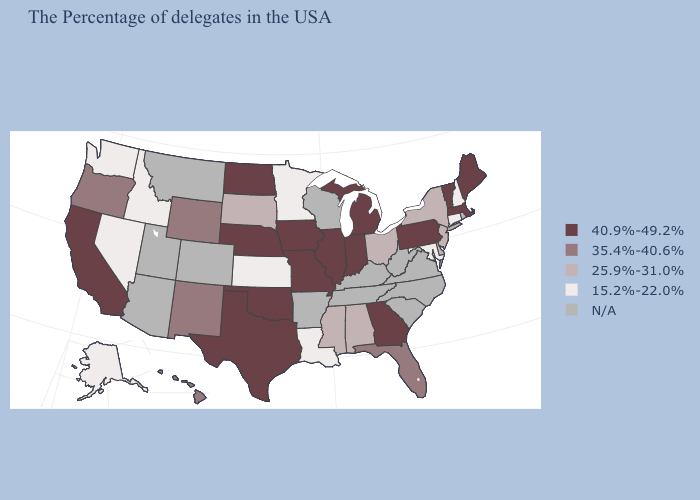What is the value of Vermont?
Keep it brief. 40.9%-49.2%. What is the lowest value in the USA?
Answer briefly. 15.2%-22.0%. Among the states that border Tennessee , which have the lowest value?
Give a very brief answer. Alabama, Mississippi. What is the value of Indiana?
Give a very brief answer. 40.9%-49.2%. What is the lowest value in states that border Maryland?
Answer briefly. 25.9%-31.0%. Name the states that have a value in the range 25.9%-31.0%?
Quick response, please. New York, New Jersey, Delaware, Ohio, Alabama, Mississippi, South Dakota. What is the highest value in the West ?
Quick response, please. 40.9%-49.2%. What is the value of Tennessee?
Quick response, please. N/A. Does the map have missing data?
Give a very brief answer. Yes. What is the value of Delaware?
Answer briefly. 25.9%-31.0%. What is the value of Alabama?
Keep it brief. 25.9%-31.0%. Name the states that have a value in the range N/A?
Quick response, please. Rhode Island, Virginia, North Carolina, South Carolina, West Virginia, Kentucky, Tennessee, Wisconsin, Arkansas, Colorado, Utah, Montana, Arizona. Name the states that have a value in the range 25.9%-31.0%?
Give a very brief answer. New York, New Jersey, Delaware, Ohio, Alabama, Mississippi, South Dakota. What is the lowest value in the Northeast?
Be succinct. 15.2%-22.0%. 